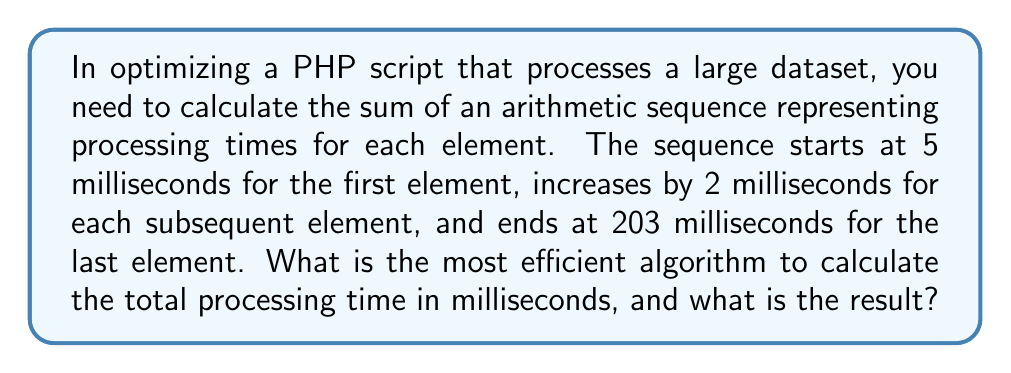Teach me how to tackle this problem. To solve this problem efficiently, we can use the formula for the sum of an arithmetic sequence:

$$ S = \frac{n(a_1 + a_n)}{2} $$

Where:
$S$ is the sum of the sequence
$n$ is the number of terms
$a_1$ is the first term
$a_n$ is the last term

Step 1: Identify the known values
$a_1 = 5$ (first term)
$a_n = 203$ (last term)
$d = 2$ (common difference)

Step 2: Calculate the number of terms
We can use the arithmetic sequence formula:
$$ a_n = a_1 + (n-1)d $$
$$ 203 = 5 + (n-1)2 $$
$$ 198 = (n-1)2 $$
$$ 99 = n-1 $$
$$ n = 100 $$

Step 3: Apply the sum formula
$$ S = \frac{100(5 + 203)}{2} $$
$$ S = \frac{100(208)}{2} $$
$$ S = 10400 $$

This algorithm is O(1) in time complexity, making it highly efficient for large datasets.
Answer: 10400 milliseconds 